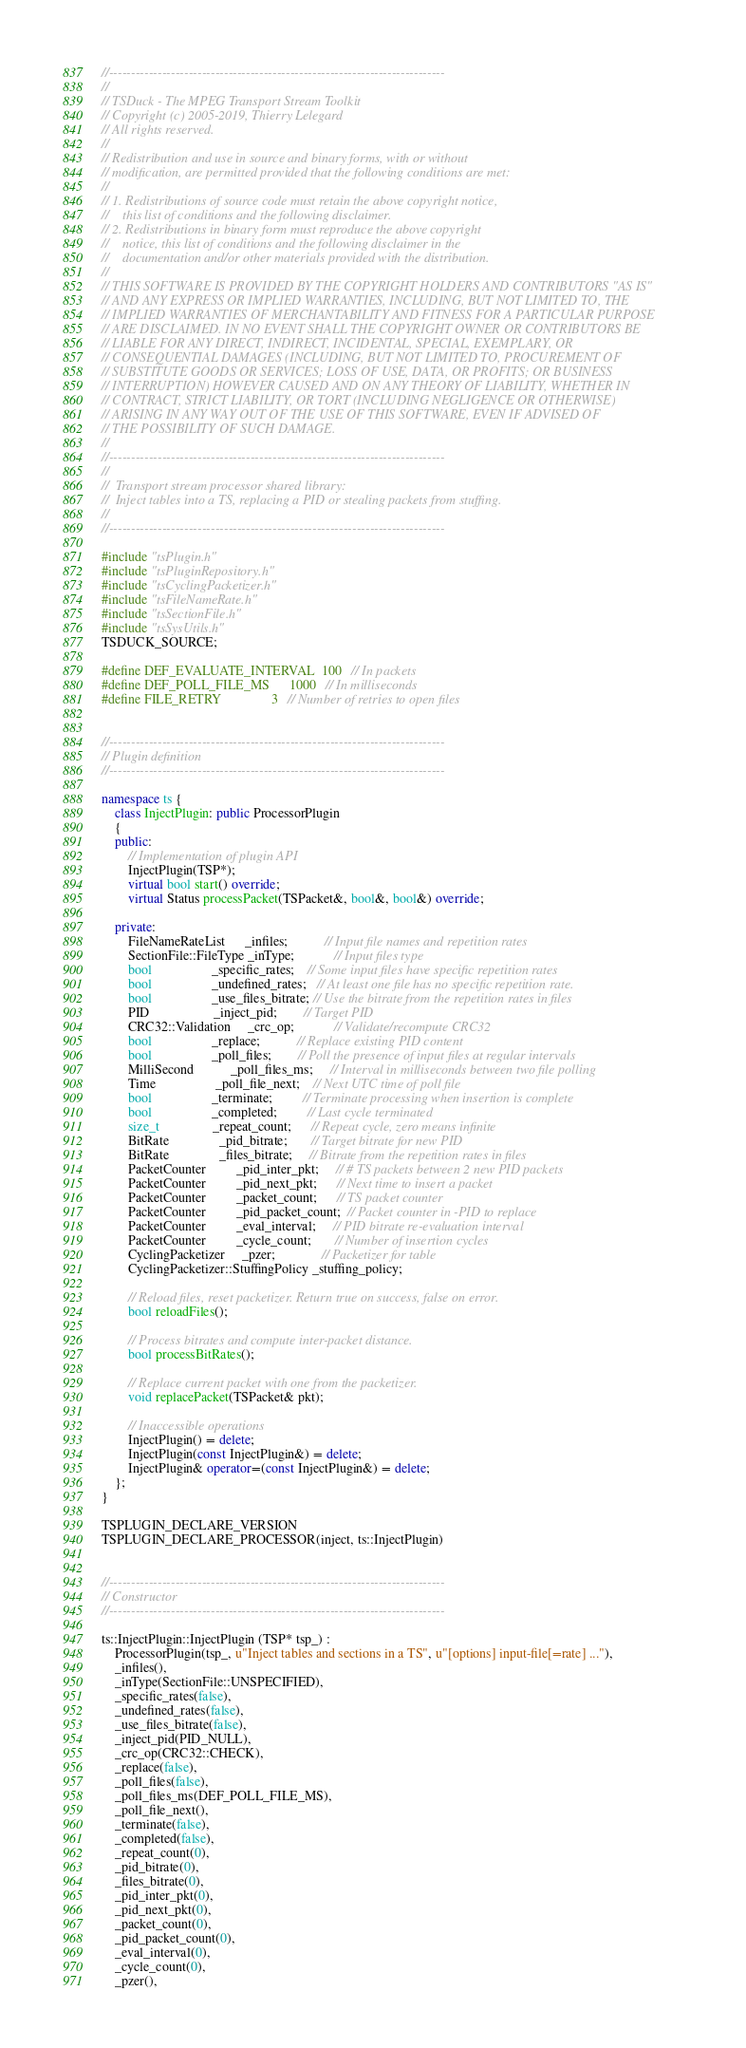Convert code to text. <code><loc_0><loc_0><loc_500><loc_500><_C++_>//----------------------------------------------------------------------------
//
// TSDuck - The MPEG Transport Stream Toolkit
// Copyright (c) 2005-2019, Thierry Lelegard
// All rights reserved.
//
// Redistribution and use in source and binary forms, with or without
// modification, are permitted provided that the following conditions are met:
//
// 1. Redistributions of source code must retain the above copyright notice,
//    this list of conditions and the following disclaimer.
// 2. Redistributions in binary form must reproduce the above copyright
//    notice, this list of conditions and the following disclaimer in the
//    documentation and/or other materials provided with the distribution.
//
// THIS SOFTWARE IS PROVIDED BY THE COPYRIGHT HOLDERS AND CONTRIBUTORS "AS IS"
// AND ANY EXPRESS OR IMPLIED WARRANTIES, INCLUDING, BUT NOT LIMITED TO, THE
// IMPLIED WARRANTIES OF MERCHANTABILITY AND FITNESS FOR A PARTICULAR PURPOSE
// ARE DISCLAIMED. IN NO EVENT SHALL THE COPYRIGHT OWNER OR CONTRIBUTORS BE
// LIABLE FOR ANY DIRECT, INDIRECT, INCIDENTAL, SPECIAL, EXEMPLARY, OR
// CONSEQUENTIAL DAMAGES (INCLUDING, BUT NOT LIMITED TO, PROCUREMENT OF
// SUBSTITUTE GOODS OR SERVICES; LOSS OF USE, DATA, OR PROFITS; OR BUSINESS
// INTERRUPTION) HOWEVER CAUSED AND ON ANY THEORY OF LIABILITY, WHETHER IN
// CONTRACT, STRICT LIABILITY, OR TORT (INCLUDING NEGLIGENCE OR OTHERWISE)
// ARISING IN ANY WAY OUT OF THE USE OF THIS SOFTWARE, EVEN IF ADVISED OF
// THE POSSIBILITY OF SUCH DAMAGE.
//
//----------------------------------------------------------------------------
//
//  Transport stream processor shared library:
//  Inject tables into a TS, replacing a PID or stealing packets from stuffing.
//
//----------------------------------------------------------------------------

#include "tsPlugin.h"
#include "tsPluginRepository.h"
#include "tsCyclingPacketizer.h"
#include "tsFileNameRate.h"
#include "tsSectionFile.h"
#include "tsSysUtils.h"
TSDUCK_SOURCE;

#define DEF_EVALUATE_INTERVAL  100   // In packets
#define DEF_POLL_FILE_MS      1000   // In milliseconds
#define FILE_RETRY               3   // Number of retries to open files


//----------------------------------------------------------------------------
// Plugin definition
//----------------------------------------------------------------------------

namespace ts {
    class InjectPlugin: public ProcessorPlugin
    {
    public:
        // Implementation of plugin API
        InjectPlugin(TSP*);
        virtual bool start() override;
        virtual Status processPacket(TSPacket&, bool&, bool&) override;

    private:
        FileNameRateList      _infiles;           // Input file names and repetition rates
        SectionFile::FileType _inType;            // Input files type
        bool                  _specific_rates;    // Some input files have specific repetition rates
        bool                  _undefined_rates;   // At least one file has no specific repetition rate.
        bool                  _use_files_bitrate; // Use the bitrate from the repetition rates in files
        PID                   _inject_pid;        // Target PID
        CRC32::Validation     _crc_op;            // Validate/recompute CRC32
        bool                  _replace;           // Replace existing PID content
        bool                  _poll_files;        // Poll the presence of input files at regular intervals
        MilliSecond           _poll_files_ms;     // Interval in milliseconds between two file polling
        Time                  _poll_file_next;    // Next UTC time of poll file
        bool                  _terminate;         // Terminate processing when insertion is complete
        bool                  _completed;         // Last cycle terminated
        size_t                _repeat_count;      // Repeat cycle, zero means infinite
        BitRate               _pid_bitrate;       // Target bitrate for new PID
        BitRate               _files_bitrate;     // Bitrate from the repetition rates in files
        PacketCounter         _pid_inter_pkt;     // # TS packets between 2 new PID packets
        PacketCounter         _pid_next_pkt;      // Next time to insert a packet
        PacketCounter         _packet_count;      // TS packet counter
        PacketCounter         _pid_packet_count;  // Packet counter in -PID to replace
        PacketCounter         _eval_interval;     // PID bitrate re-evaluation interval
        PacketCounter         _cycle_count;       // Number of insertion cycles
        CyclingPacketizer     _pzer;              // Packetizer for table
        CyclingPacketizer::StuffingPolicy _stuffing_policy;

        // Reload files, reset packetizer. Return true on success, false on error.
        bool reloadFiles();

        // Process bitrates and compute inter-packet distance.
        bool processBitRates();

        // Replace current packet with one from the packetizer.
        void replacePacket(TSPacket& pkt);

        // Inaccessible operations
        InjectPlugin() = delete;
        InjectPlugin(const InjectPlugin&) = delete;
        InjectPlugin& operator=(const InjectPlugin&) = delete;
    };
}

TSPLUGIN_DECLARE_VERSION
TSPLUGIN_DECLARE_PROCESSOR(inject, ts::InjectPlugin)


//----------------------------------------------------------------------------
// Constructor
//----------------------------------------------------------------------------

ts::InjectPlugin::InjectPlugin (TSP* tsp_) :
    ProcessorPlugin(tsp_, u"Inject tables and sections in a TS", u"[options] input-file[=rate] ..."),
    _infiles(),
    _inType(SectionFile::UNSPECIFIED),
    _specific_rates(false),
    _undefined_rates(false),
    _use_files_bitrate(false),
    _inject_pid(PID_NULL),
    _crc_op(CRC32::CHECK),
    _replace(false),
    _poll_files(false),
    _poll_files_ms(DEF_POLL_FILE_MS),
    _poll_file_next(),
    _terminate(false),
    _completed(false),
    _repeat_count(0),
    _pid_bitrate(0),
    _files_bitrate(0),
    _pid_inter_pkt(0),
    _pid_next_pkt(0),
    _packet_count(0),
    _pid_packet_count(0),
    _eval_interval(0),
    _cycle_count(0),
    _pzer(),</code> 